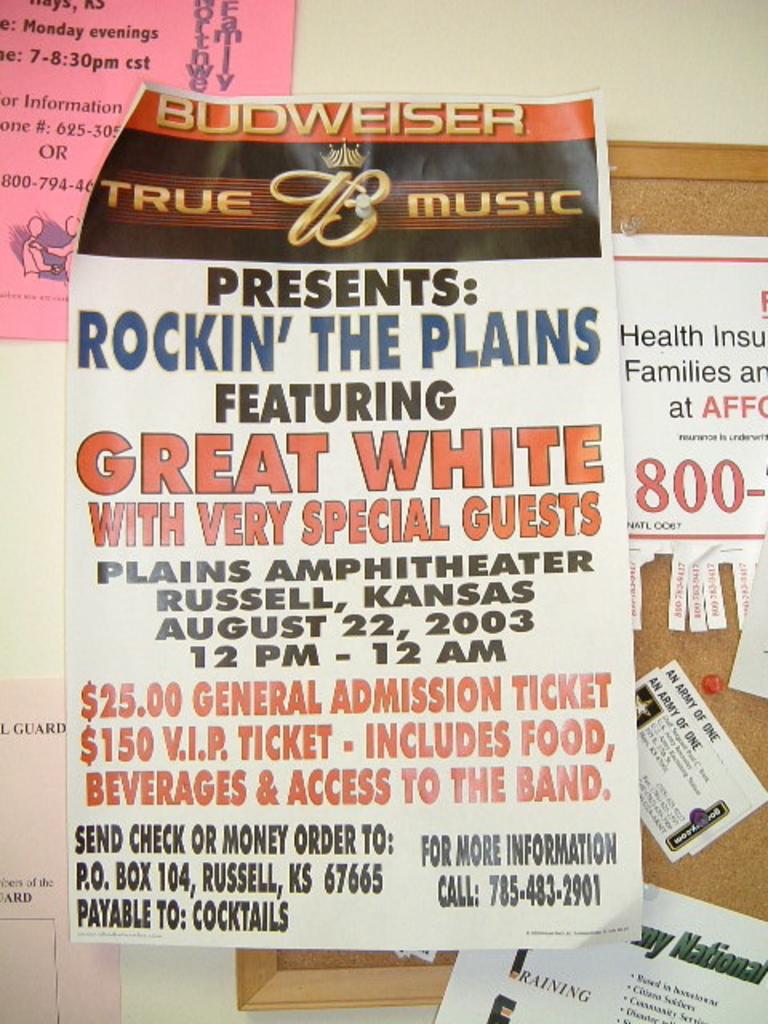Who is sponsoring the event on the poster?
Make the answer very short. Budweiser. What band is the event featuring?
Give a very brief answer. Great white. 